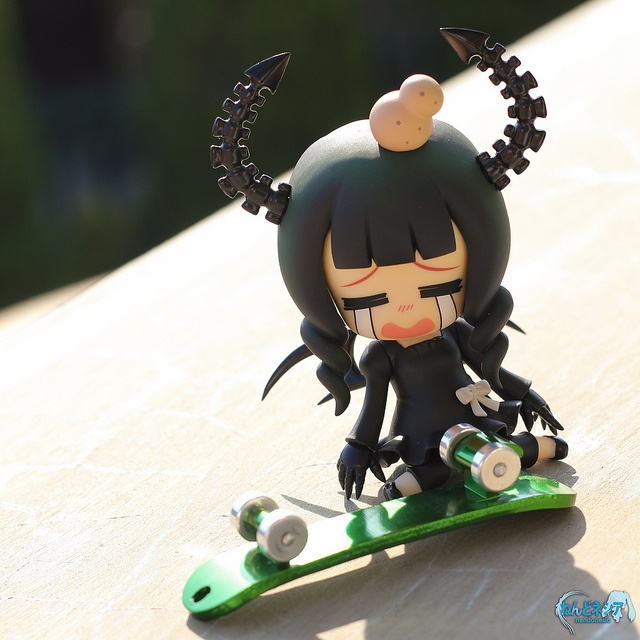Describe the objects in this image and their specific colors. I can see a skateboard in darkgreen, ivory, and black tones in this image. 